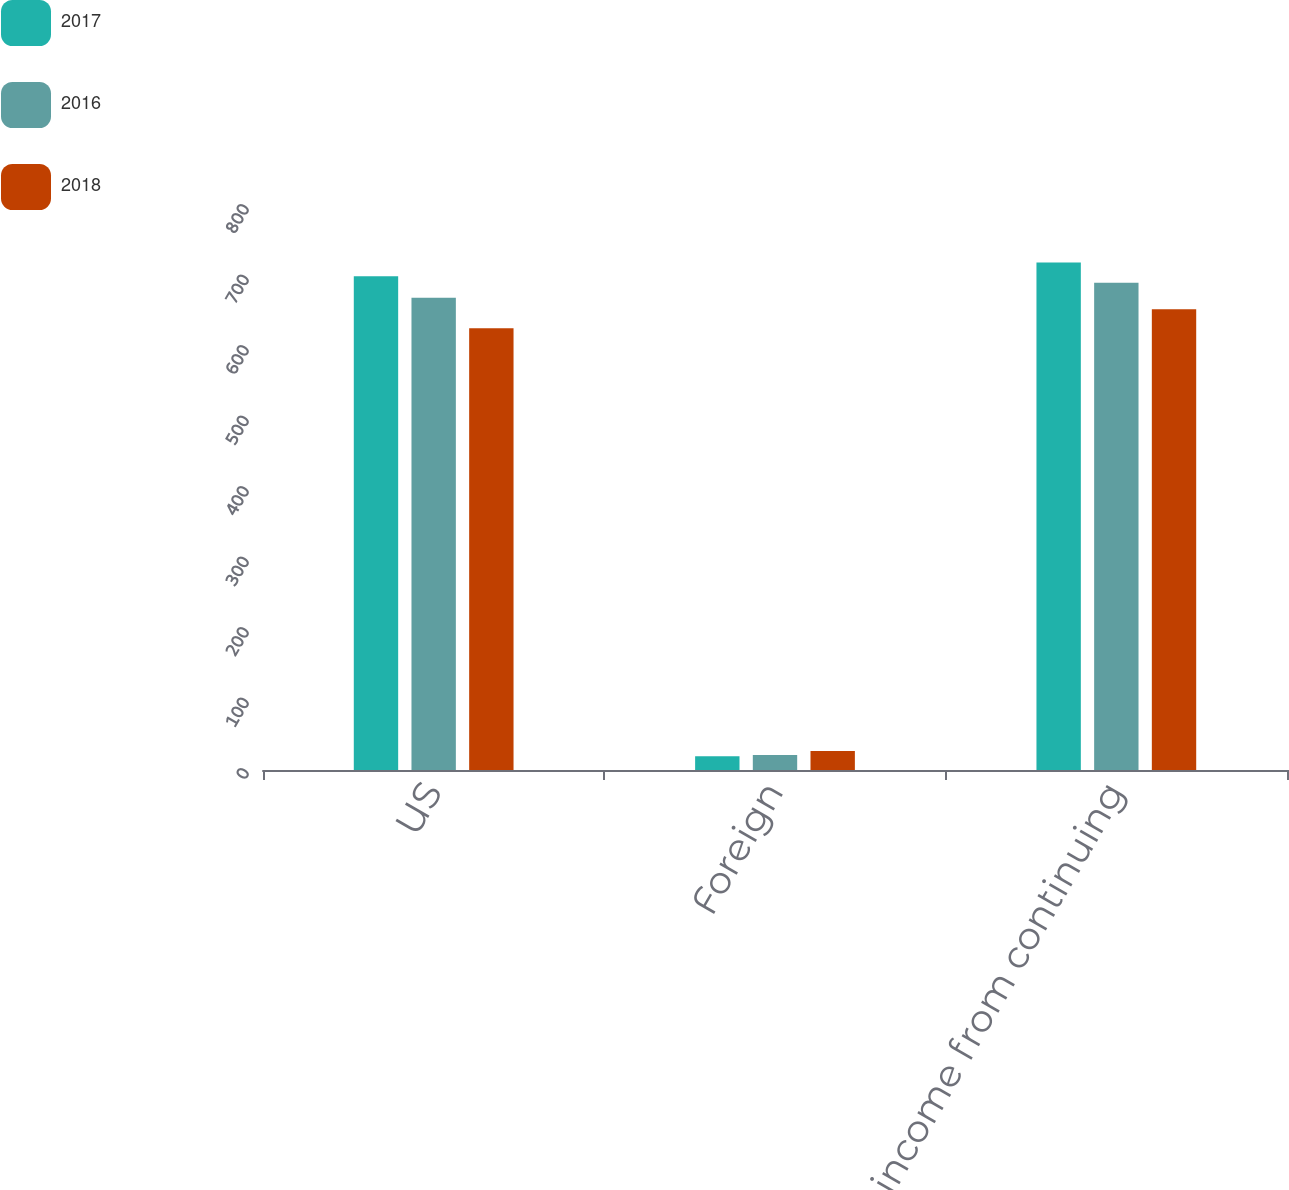Convert chart. <chart><loc_0><loc_0><loc_500><loc_500><stacked_bar_chart><ecel><fcel>US<fcel>Foreign<fcel>Total income from continuing<nl><fcel>2017<fcel>700.2<fcel>19.5<fcel>719.7<nl><fcel>2016<fcel>669.9<fcel>21.1<fcel>691<nl><fcel>2018<fcel>626.6<fcel>27.1<fcel>653.7<nl></chart> 